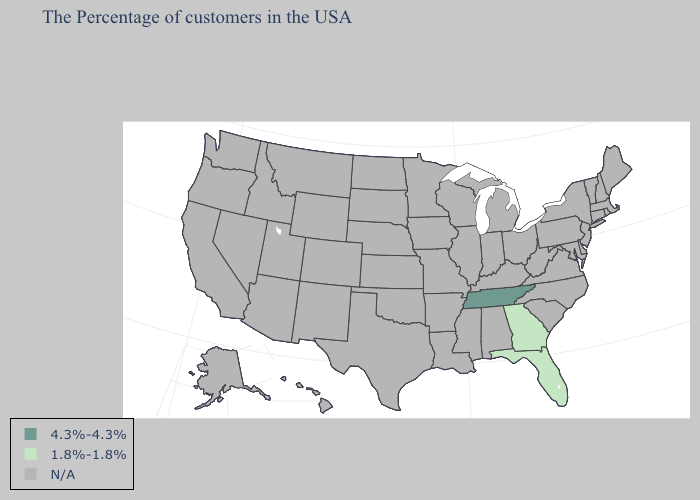What is the value of Nevada?
Short answer required. N/A. What is the value of Mississippi?
Concise answer only. N/A. Name the states that have a value in the range 4.3%-4.3%?
Keep it brief. Tennessee. Name the states that have a value in the range 4.3%-4.3%?
Quick response, please. Tennessee. What is the lowest value in the USA?
Answer briefly. 1.8%-1.8%. What is the value of Missouri?
Give a very brief answer. N/A. Name the states that have a value in the range 1.8%-1.8%?
Concise answer only. Florida, Georgia. Name the states that have a value in the range N/A?
Concise answer only. Maine, Massachusetts, Rhode Island, New Hampshire, Vermont, Connecticut, New York, New Jersey, Delaware, Maryland, Pennsylvania, Virginia, North Carolina, South Carolina, West Virginia, Ohio, Michigan, Kentucky, Indiana, Alabama, Wisconsin, Illinois, Mississippi, Louisiana, Missouri, Arkansas, Minnesota, Iowa, Kansas, Nebraska, Oklahoma, Texas, South Dakota, North Dakota, Wyoming, Colorado, New Mexico, Utah, Montana, Arizona, Idaho, Nevada, California, Washington, Oregon, Alaska, Hawaii. What is the lowest value in the USA?
Concise answer only. 1.8%-1.8%. Does Florida have the highest value in the USA?
Keep it brief. No. What is the value of Illinois?
Give a very brief answer. N/A. Name the states that have a value in the range N/A?
Answer briefly. Maine, Massachusetts, Rhode Island, New Hampshire, Vermont, Connecticut, New York, New Jersey, Delaware, Maryland, Pennsylvania, Virginia, North Carolina, South Carolina, West Virginia, Ohio, Michigan, Kentucky, Indiana, Alabama, Wisconsin, Illinois, Mississippi, Louisiana, Missouri, Arkansas, Minnesota, Iowa, Kansas, Nebraska, Oklahoma, Texas, South Dakota, North Dakota, Wyoming, Colorado, New Mexico, Utah, Montana, Arizona, Idaho, Nevada, California, Washington, Oregon, Alaska, Hawaii. What is the value of Georgia?
Be succinct. 1.8%-1.8%. Name the states that have a value in the range 4.3%-4.3%?
Give a very brief answer. Tennessee. 